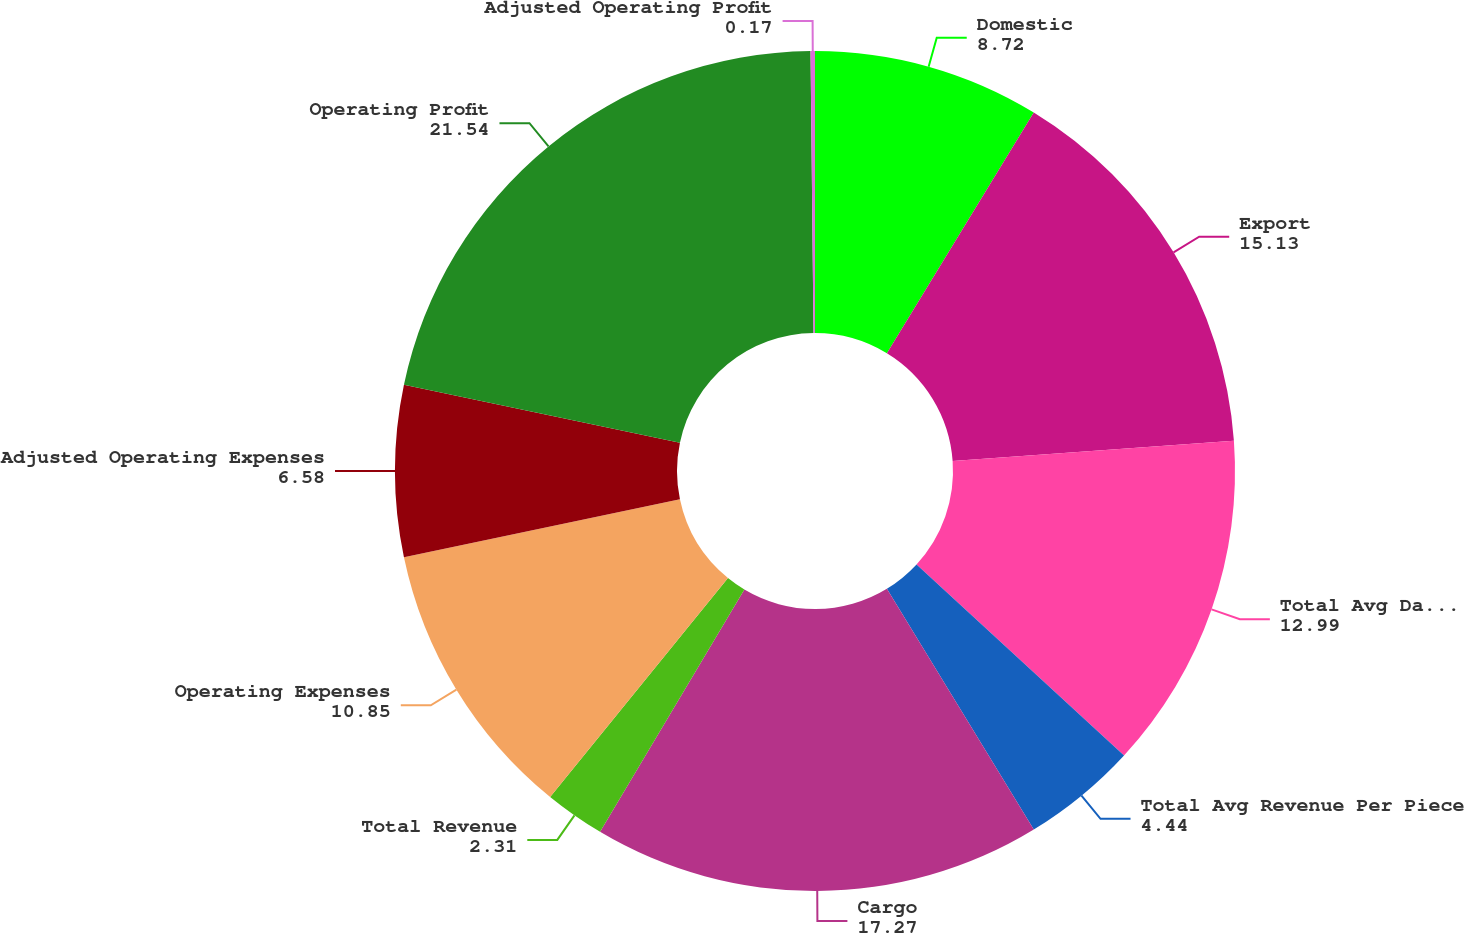Convert chart to OTSL. <chart><loc_0><loc_0><loc_500><loc_500><pie_chart><fcel>Domestic<fcel>Export<fcel>Total Avg Daily Package Volume<fcel>Total Avg Revenue Per Piece<fcel>Cargo<fcel>Total Revenue<fcel>Operating Expenses<fcel>Adjusted Operating Expenses<fcel>Operating Profit<fcel>Adjusted Operating Profit<nl><fcel>8.72%<fcel>15.13%<fcel>12.99%<fcel>4.44%<fcel>17.27%<fcel>2.31%<fcel>10.85%<fcel>6.58%<fcel>21.54%<fcel>0.17%<nl></chart> 